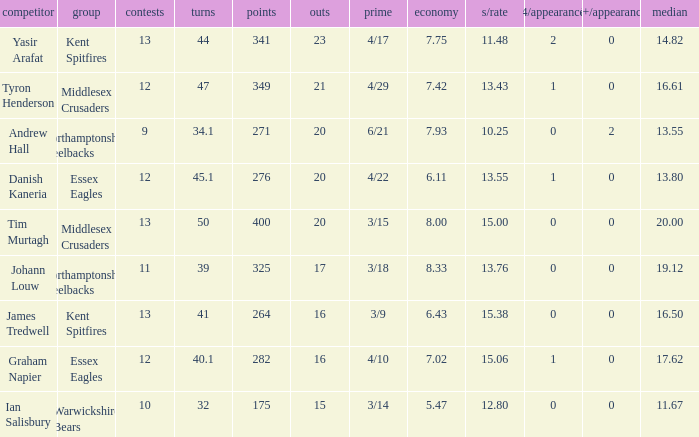Name the most wickets for best is 4/22 20.0. 